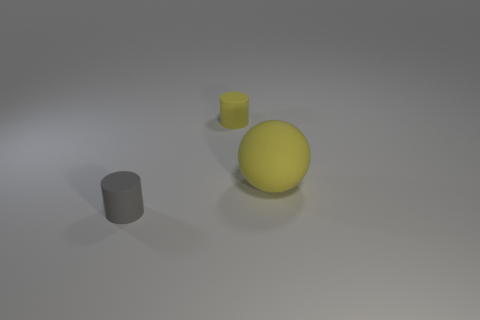There is another small thing that is the same shape as the gray rubber object; what is its color?
Keep it short and to the point. Yellow. Is the shape of the tiny gray matte thing the same as the small yellow thing?
Offer a terse response. Yes. There is a small cylinder behind the rubber sphere; is its color the same as the large thing?
Your answer should be compact. Yes. Is the number of small gray objects to the right of the yellow ball the same as the number of small green metal cylinders?
Offer a terse response. Yes. What is the color of the object that is the same size as the yellow cylinder?
Make the answer very short. Gray. Are there any other small gray things of the same shape as the tiny gray matte thing?
Offer a very short reply. No. What is the material of the small cylinder that is in front of the tiny yellow rubber cylinder on the right side of the tiny matte cylinder in front of the large yellow thing?
Your response must be concise. Rubber. What number of other objects are the same size as the yellow cylinder?
Ensure brevity in your answer.  1. What is the color of the large object?
Keep it short and to the point. Yellow. What number of matte things are small yellow cylinders or big objects?
Keep it short and to the point. 2. 